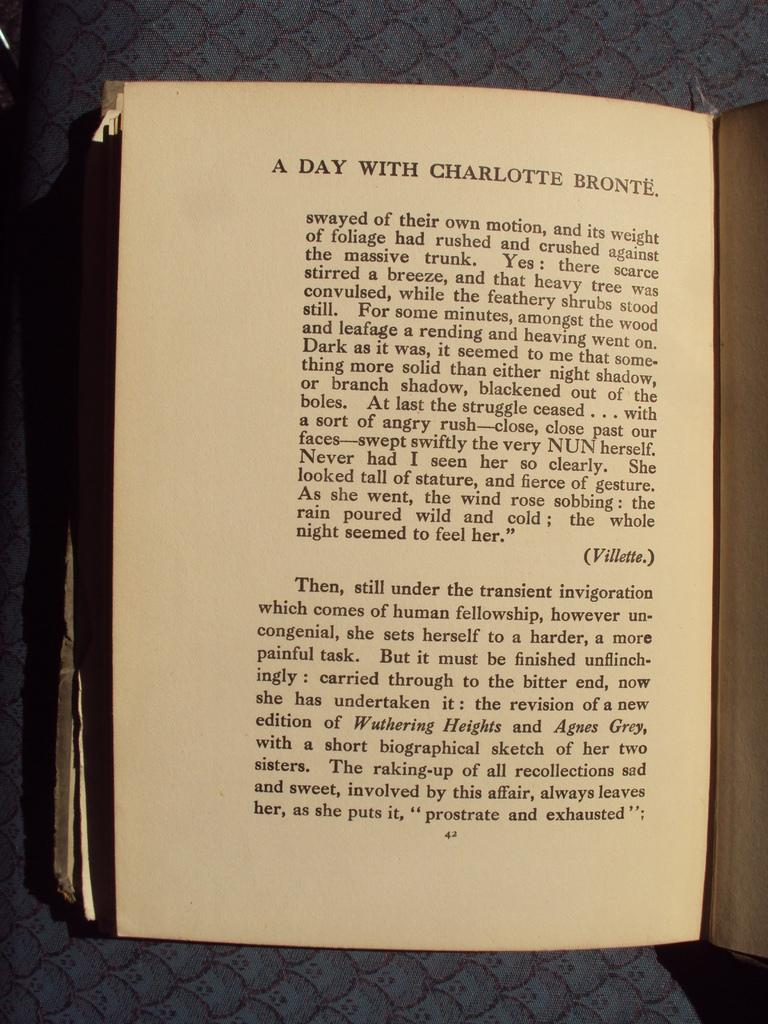<image>
Provide a brief description of the given image. A page that is titled "A day with Charlotte Bronte". 